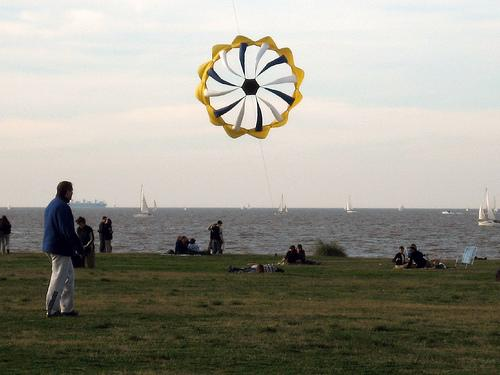The item in the sky looks most like what? wheel 